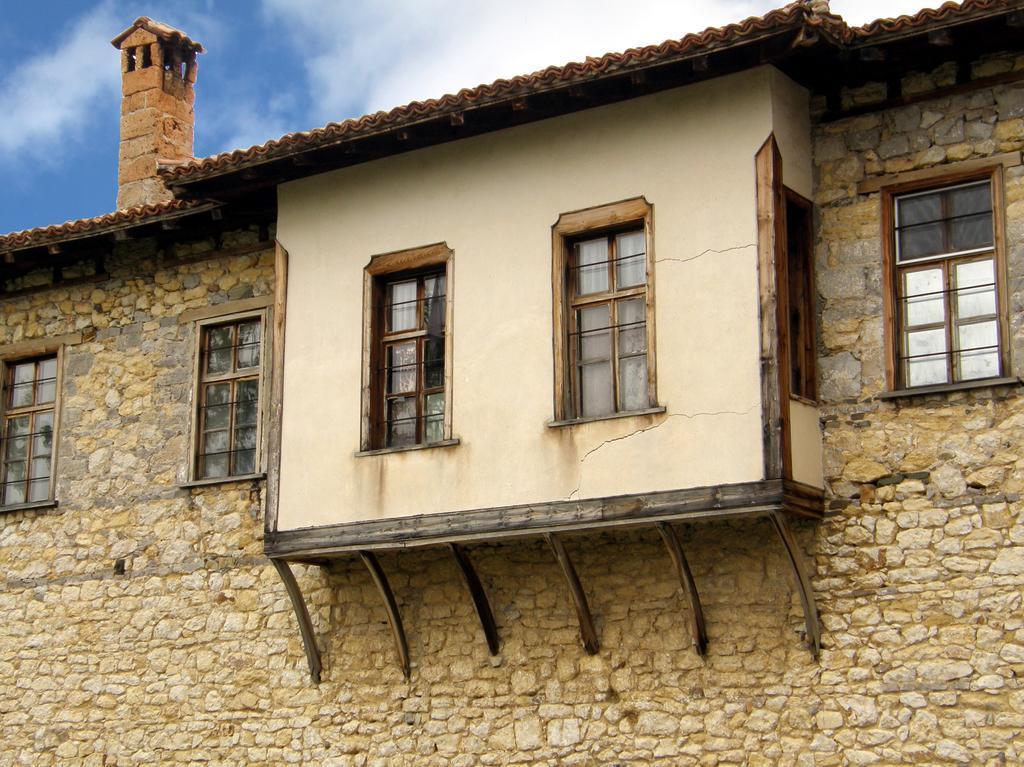In one or two sentences, can you explain what this image depicts? In this image there is a wall of a building. There are glass windows to the wall of the building. At the top there is the sky. 